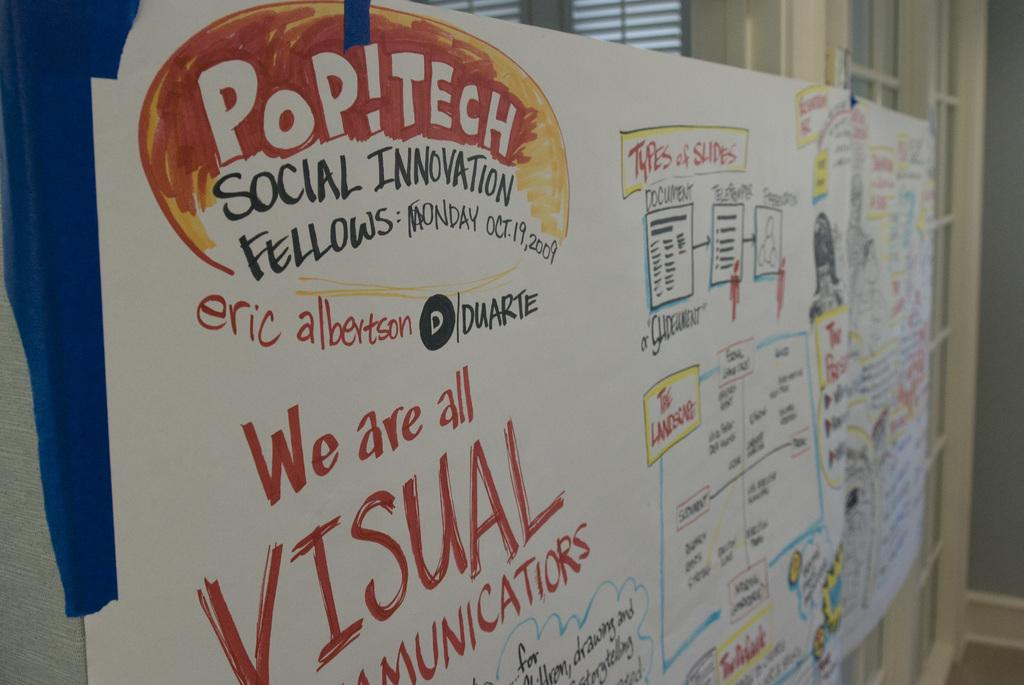<image>
Provide a brief description of the given image. A white board has writing on it that states that we are all visual communicators. 